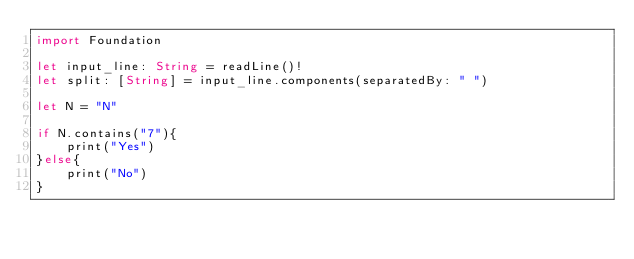<code> <loc_0><loc_0><loc_500><loc_500><_Swift_>import Foundation
 
let input_line: String = readLine()!
let split: [String] = input_line.components(separatedBy: " ")
 
let N = "N"

if N.contains("7"){
    print("Yes")
}else{
    print("No")
}
</code> 